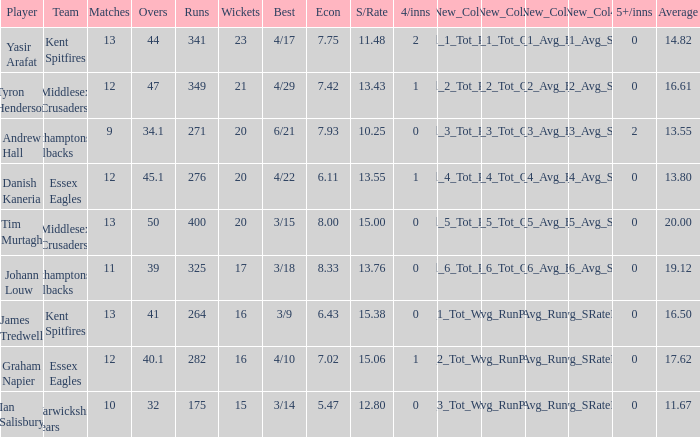Name the most wickets for best is 4/22 20.0. 